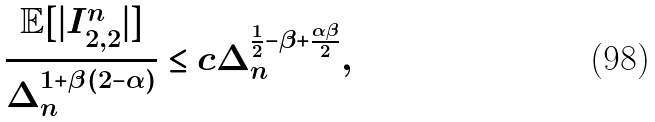<formula> <loc_0><loc_0><loc_500><loc_500>\frac { \mathbb { E } [ | I _ { 2 , 2 } ^ { n } | ] } { \Delta _ { n } ^ { 1 + \beta ( 2 - \alpha ) } } \leq c \Delta _ { n } ^ { \frac { 1 } { 2 } - \beta + \frac { \alpha \beta } { 2 } } ,</formula> 